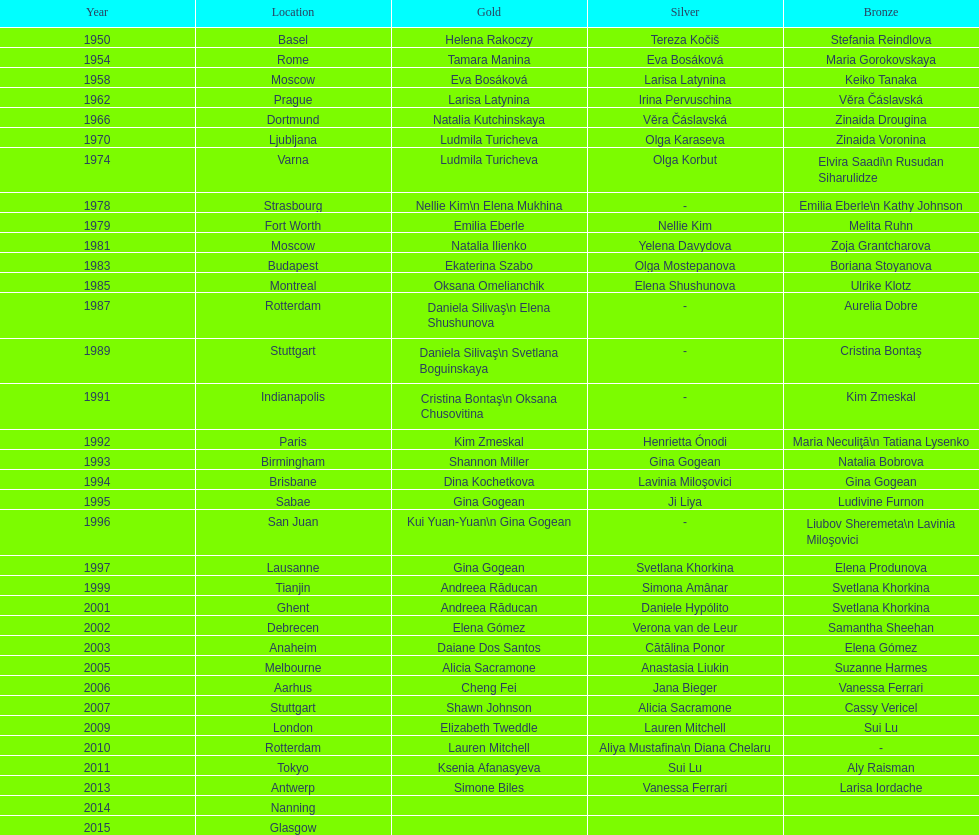How many back-to-back floor exercise gold medals did andreea raducan, the romanian star, claim at the world championships? 2. 